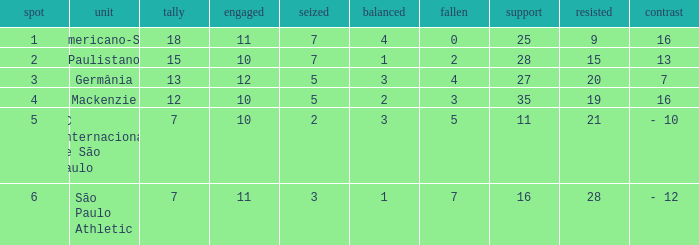Name the least for when played is 12 27.0. 